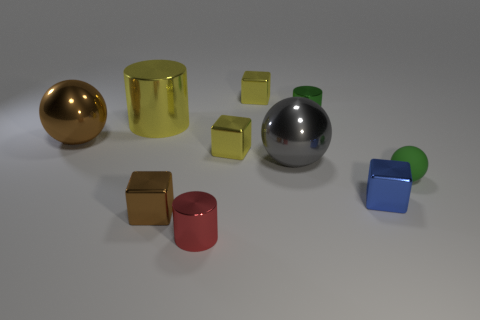Are there an equal number of small brown cubes on the right side of the green metallic object and small metal cubes behind the matte object?
Make the answer very short. No. How many rubber things are there?
Your response must be concise. 1. Is the number of brown objects that are behind the blue block greater than the number of big red spheres?
Provide a succinct answer. Yes. There is a brown object that is in front of the large gray shiny sphere; what material is it?
Give a very brief answer. Metal. What is the color of the other tiny metal object that is the same shape as the tiny red object?
Your answer should be very brief. Green. What number of shiny blocks have the same color as the big cylinder?
Ensure brevity in your answer.  2. Is the size of the cylinder in front of the tiny brown block the same as the brown metal thing behind the brown block?
Make the answer very short. No. Do the green rubber ball and the metallic cylinder that is on the right side of the large gray metallic object have the same size?
Your answer should be very brief. Yes. The gray thing has what size?
Offer a terse response. Large. There is another large ball that is the same material as the brown sphere; what is its color?
Your answer should be very brief. Gray. 